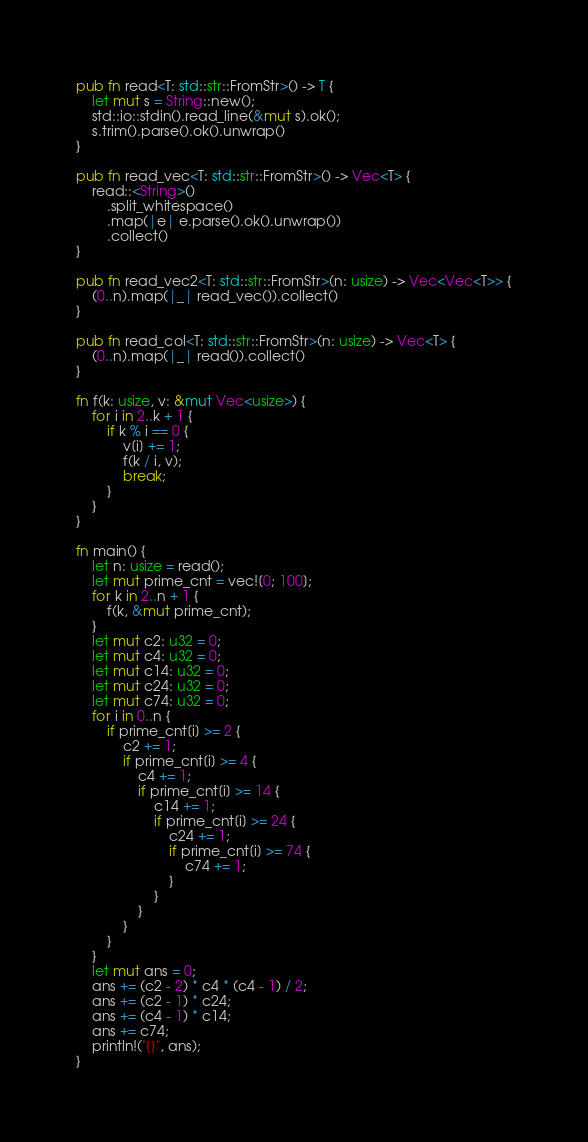Convert code to text. <code><loc_0><loc_0><loc_500><loc_500><_Rust_>pub fn read<T: std::str::FromStr>() -> T {
    let mut s = String::new();
    std::io::stdin().read_line(&mut s).ok();
    s.trim().parse().ok().unwrap()
}

pub fn read_vec<T: std::str::FromStr>() -> Vec<T> {
    read::<String>()
        .split_whitespace()
        .map(|e| e.parse().ok().unwrap())
        .collect()
}

pub fn read_vec2<T: std::str::FromStr>(n: usize) -> Vec<Vec<T>> {
    (0..n).map(|_| read_vec()).collect()
}

pub fn read_col<T: std::str::FromStr>(n: usize) -> Vec<T> {
    (0..n).map(|_| read()).collect()
}

fn f(k: usize, v: &mut Vec<usize>) {
    for i in 2..k + 1 {
        if k % i == 0 {
            v[i] += 1;
            f(k / i, v);
            break;
        }
    }
}

fn main() {
    let n: usize = read();
    let mut prime_cnt = vec![0; 100];
    for k in 2..n + 1 {
        f(k, &mut prime_cnt);
    }
    let mut c2: u32 = 0;
    let mut c4: u32 = 0;
    let mut c14: u32 = 0;
    let mut c24: u32 = 0;
    let mut c74: u32 = 0;
    for i in 0..n {
        if prime_cnt[i] >= 2 {
            c2 += 1;
            if prime_cnt[i] >= 4 {
                c4 += 1;
                if prime_cnt[i] >= 14 {
                    c14 += 1;
                    if prime_cnt[i] >= 24 {
                        c24 += 1;
                        if prime_cnt[i] >= 74 {
                            c74 += 1;
                        }
                    }
                }
            }
        }
    }
    let mut ans = 0;
    ans += (c2 - 2) * c4 * (c4 - 1) / 2;
    ans += (c2 - 1) * c24;
    ans += (c4 - 1) * c14;
    ans += c74;
    println!("{}", ans);
}
</code> 